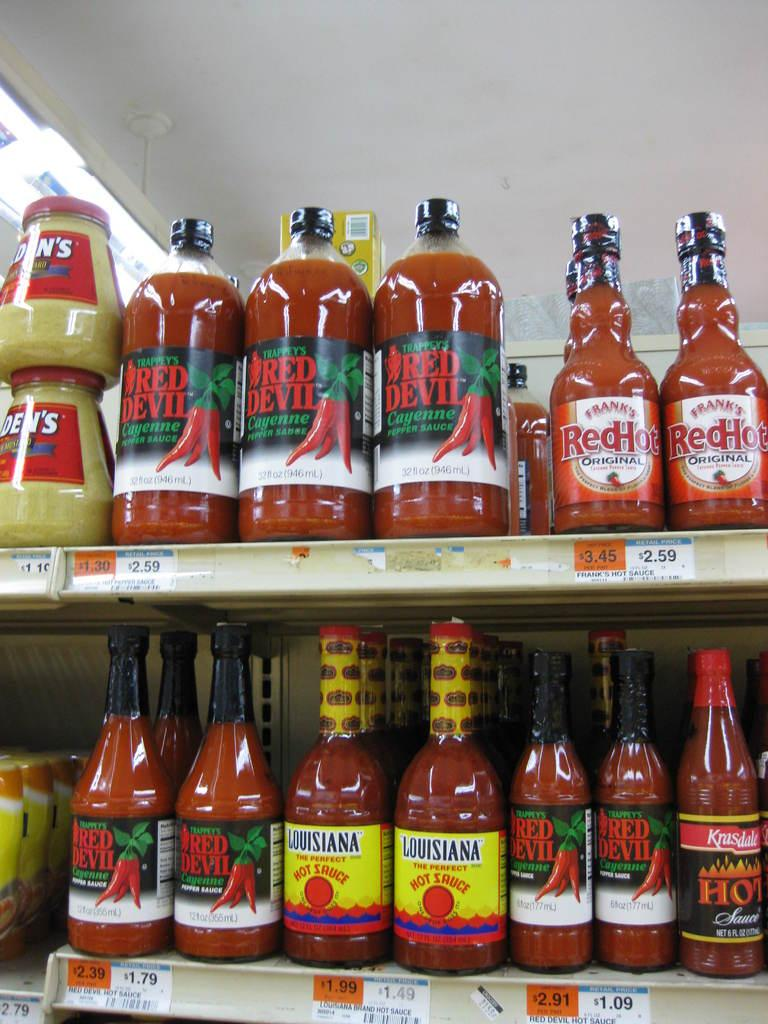<image>
Create a compact narrative representing the image presented. A shelf in a store with many brands of hot sauce like Franks Red Hot 